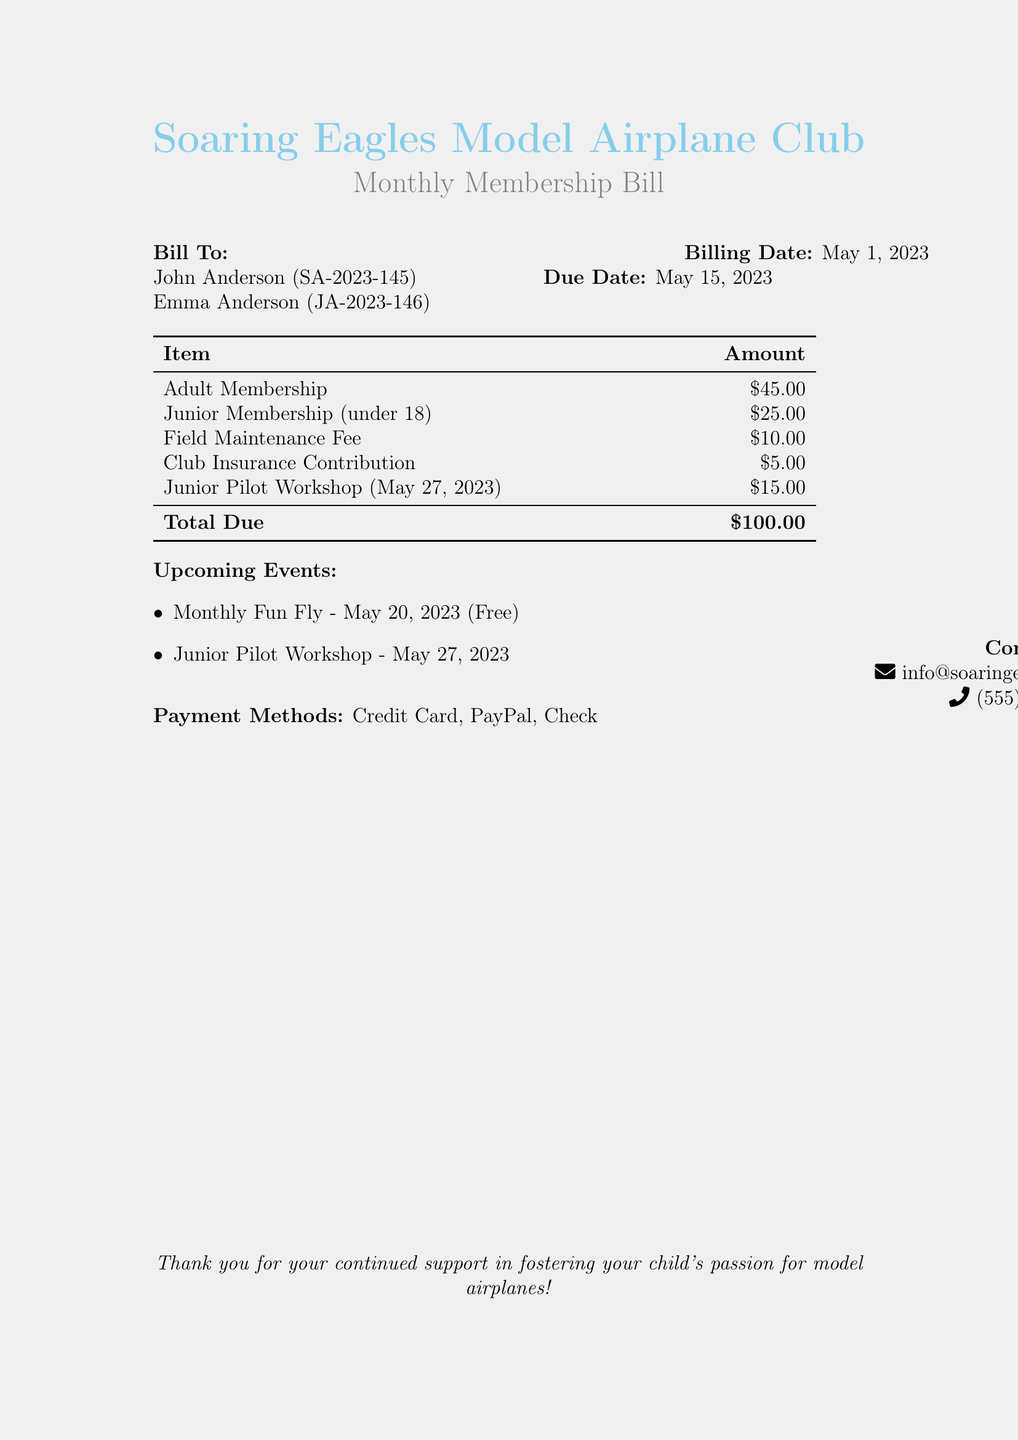What is the name of the club? The name of the club is mentioned at the top of the document as "Soaring Eagles Model Airplane Club."
Answer: Soaring Eagles Model Airplane Club What is the billing date? The billing date is specified in the billing section of the document as May 1, 2023.
Answer: May 1, 2023 What is the total due amount? The total due amount is summarized at the end of the list of fees as $100.00.
Answer: $100.00 What is the fee for adult membership? The fee for adult membership is listed as $45.00.
Answer: $45.00 When is the Junior Pilot Workshop? The date of the Junior Pilot Workshop is mentioned as May 27, 2023.
Answer: May 27, 2023 How much is the Junior Membership fee? The Junior Membership fee is detailed as $25.00 in the bill.
Answer: $25.00 What type of payment methods are accepted? The document lists the accepted payment methods as Credit Card, PayPal, and Check.
Answer: Credit Card, PayPal, Check What is the purpose of the Field Maintenance Fee? The Field Maintenance Fee covers maintenance associated with the club's facilities and is part of the bill items.
Answer: Maintenance Is there a cost for the Monthly Fun Fly event? The cost for the Monthly Fun Fly event is stated to be free in the upcoming events section.
Answer: Free 